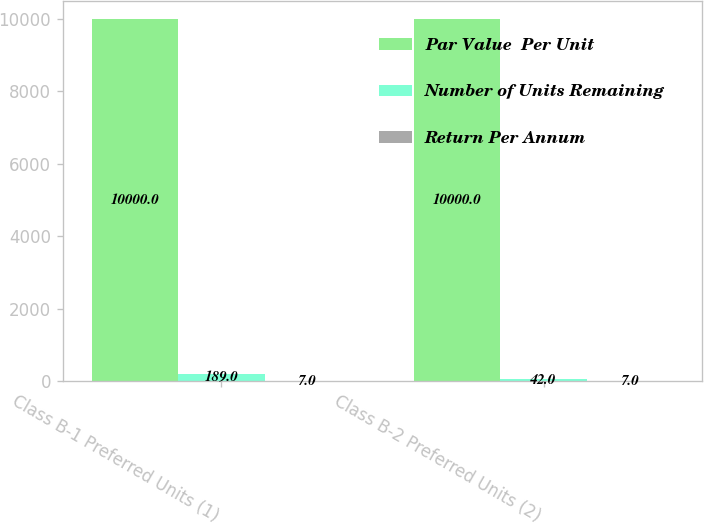<chart> <loc_0><loc_0><loc_500><loc_500><stacked_bar_chart><ecel><fcel>Class B-1 Preferred Units (1)<fcel>Class B-2 Preferred Units (2)<nl><fcel>Par Value  Per Unit<fcel>10000<fcel>10000<nl><fcel>Number of Units Remaining<fcel>189<fcel>42<nl><fcel>Return Per Annum<fcel>7<fcel>7<nl></chart> 